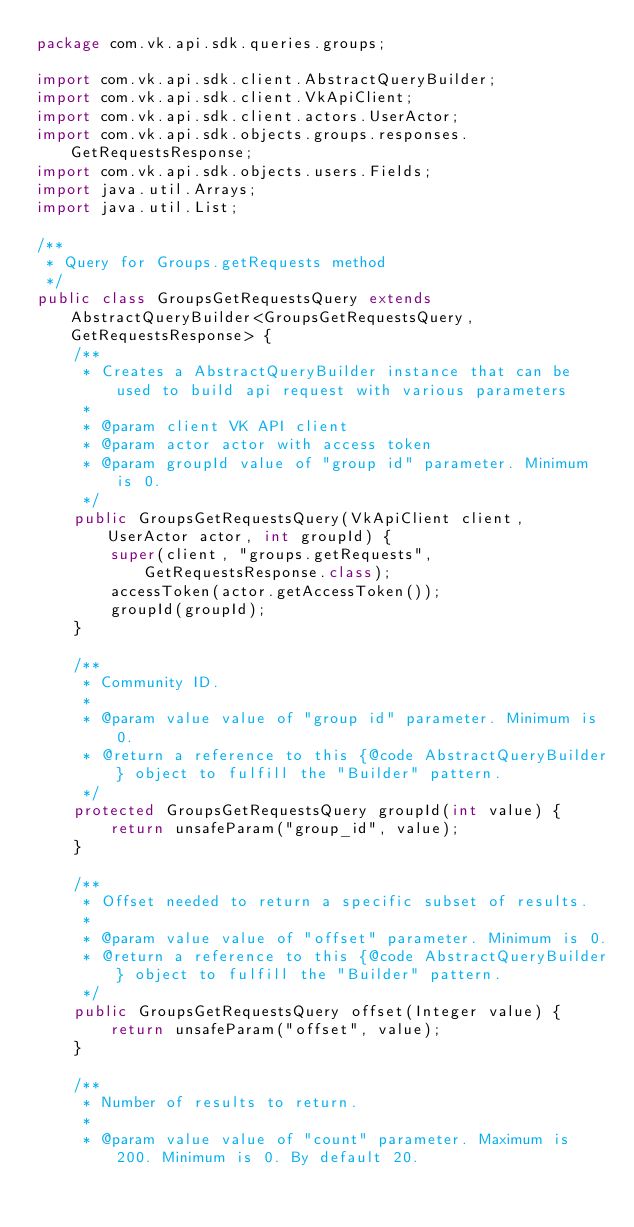Convert code to text. <code><loc_0><loc_0><loc_500><loc_500><_Java_>package com.vk.api.sdk.queries.groups;

import com.vk.api.sdk.client.AbstractQueryBuilder;
import com.vk.api.sdk.client.VkApiClient;
import com.vk.api.sdk.client.actors.UserActor;
import com.vk.api.sdk.objects.groups.responses.GetRequestsResponse;
import com.vk.api.sdk.objects.users.Fields;
import java.util.Arrays;
import java.util.List;

/**
 * Query for Groups.getRequests method
 */
public class GroupsGetRequestsQuery extends AbstractQueryBuilder<GroupsGetRequestsQuery, GetRequestsResponse> {
    /**
     * Creates a AbstractQueryBuilder instance that can be used to build api request with various parameters
     *
     * @param client VK API client
     * @param actor actor with access token
     * @param groupId value of "group id" parameter. Minimum is 0.
     */
    public GroupsGetRequestsQuery(VkApiClient client, UserActor actor, int groupId) {
        super(client, "groups.getRequests", GetRequestsResponse.class);
        accessToken(actor.getAccessToken());
        groupId(groupId);
    }

    /**
     * Community ID.
     *
     * @param value value of "group id" parameter. Minimum is 0.
     * @return a reference to this {@code AbstractQueryBuilder} object to fulfill the "Builder" pattern.
     */
    protected GroupsGetRequestsQuery groupId(int value) {
        return unsafeParam("group_id", value);
    }

    /**
     * Offset needed to return a specific subset of results.
     *
     * @param value value of "offset" parameter. Minimum is 0.
     * @return a reference to this {@code AbstractQueryBuilder} object to fulfill the "Builder" pattern.
     */
    public GroupsGetRequestsQuery offset(Integer value) {
        return unsafeParam("offset", value);
    }

    /**
     * Number of results to return.
     *
     * @param value value of "count" parameter. Maximum is 200. Minimum is 0. By default 20.</code> 